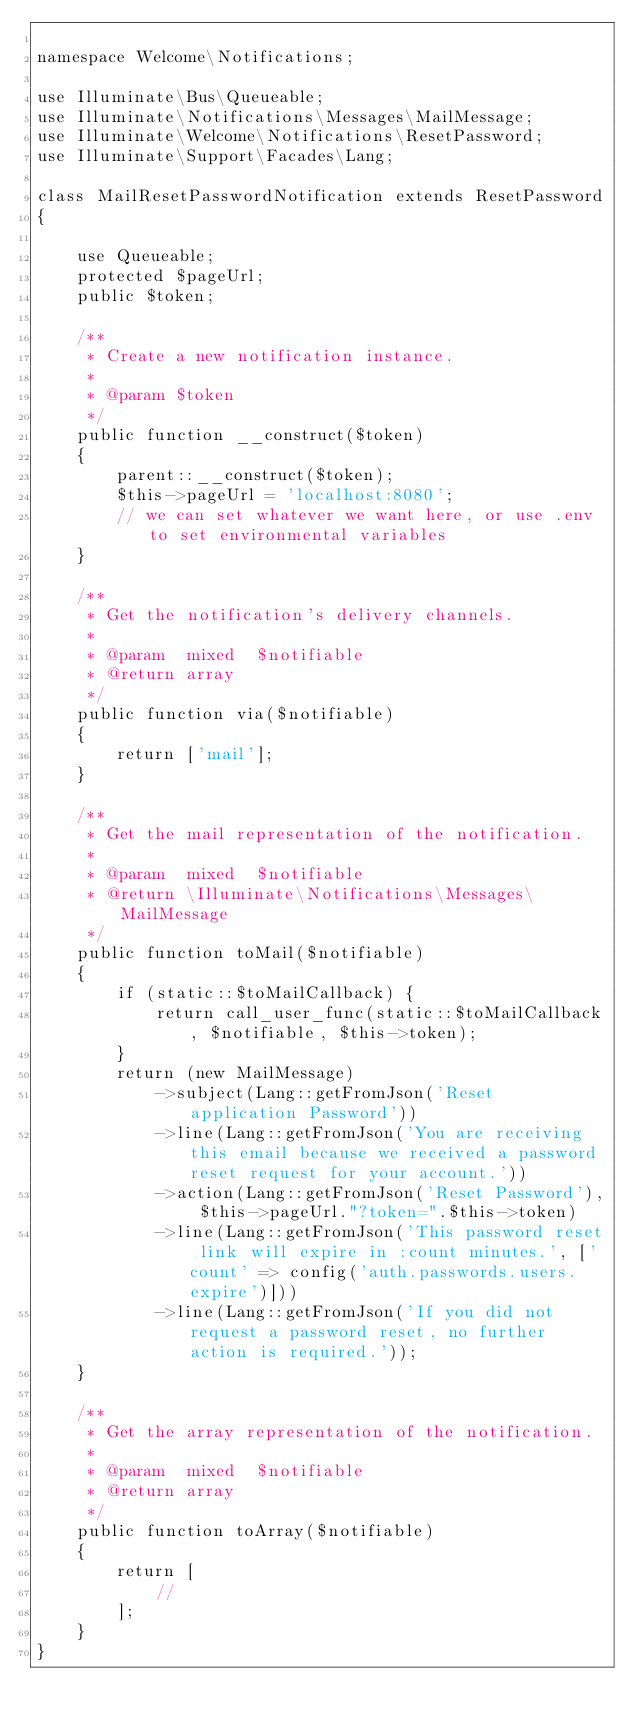<code> <loc_0><loc_0><loc_500><loc_500><_PHP_>
namespace Welcome\Notifications;

use Illuminate\Bus\Queueable;
use Illuminate\Notifications\Messages\MailMessage;
use Illuminate\Welcome\Notifications\ResetPassword;
use Illuminate\Support\Facades\Lang;

class MailResetPasswordNotification extends ResetPassword
{

    use Queueable;
    protected $pageUrl;
    public $token;

    /**
     * Create a new notification instance.
     *
     * @param $token
     */
    public function __construct($token)
    {
        parent::__construct($token);
        $this->pageUrl = 'localhost:8080';
        // we can set whatever we want here, or use .env to set environmental variables
    }

    /**
     * Get the notification's delivery channels.
     *
     * @param  mixed  $notifiable
     * @return array
     */
    public function via($notifiable)
    {
        return ['mail'];
    }

    /**
     * Get the mail representation of the notification.
     *
     * @param  mixed  $notifiable
     * @return \Illuminate\Notifications\Messages\MailMessage
     */
    public function toMail($notifiable)
    {
        if (static::$toMailCallback) {
            return call_user_func(static::$toMailCallback, $notifiable, $this->token);
        }
        return (new MailMessage)
            ->subject(Lang::getFromJson('Reset application Password'))
            ->line(Lang::getFromJson('You are receiving this email because we received a password reset request for your account.'))
            ->action(Lang::getFromJson('Reset Password'), $this->pageUrl."?token=".$this->token)
            ->line(Lang::getFromJson('This password reset link will expire in :count minutes.', ['count' => config('auth.passwords.users.expire')]))
            ->line(Lang::getFromJson('If you did not request a password reset, no further action is required.'));
    }

    /**
     * Get the array representation of the notification.
     *
     * @param  mixed  $notifiable
     * @return array
     */
    public function toArray($notifiable)
    {
        return [
            //
        ];
    }
}
</code> 